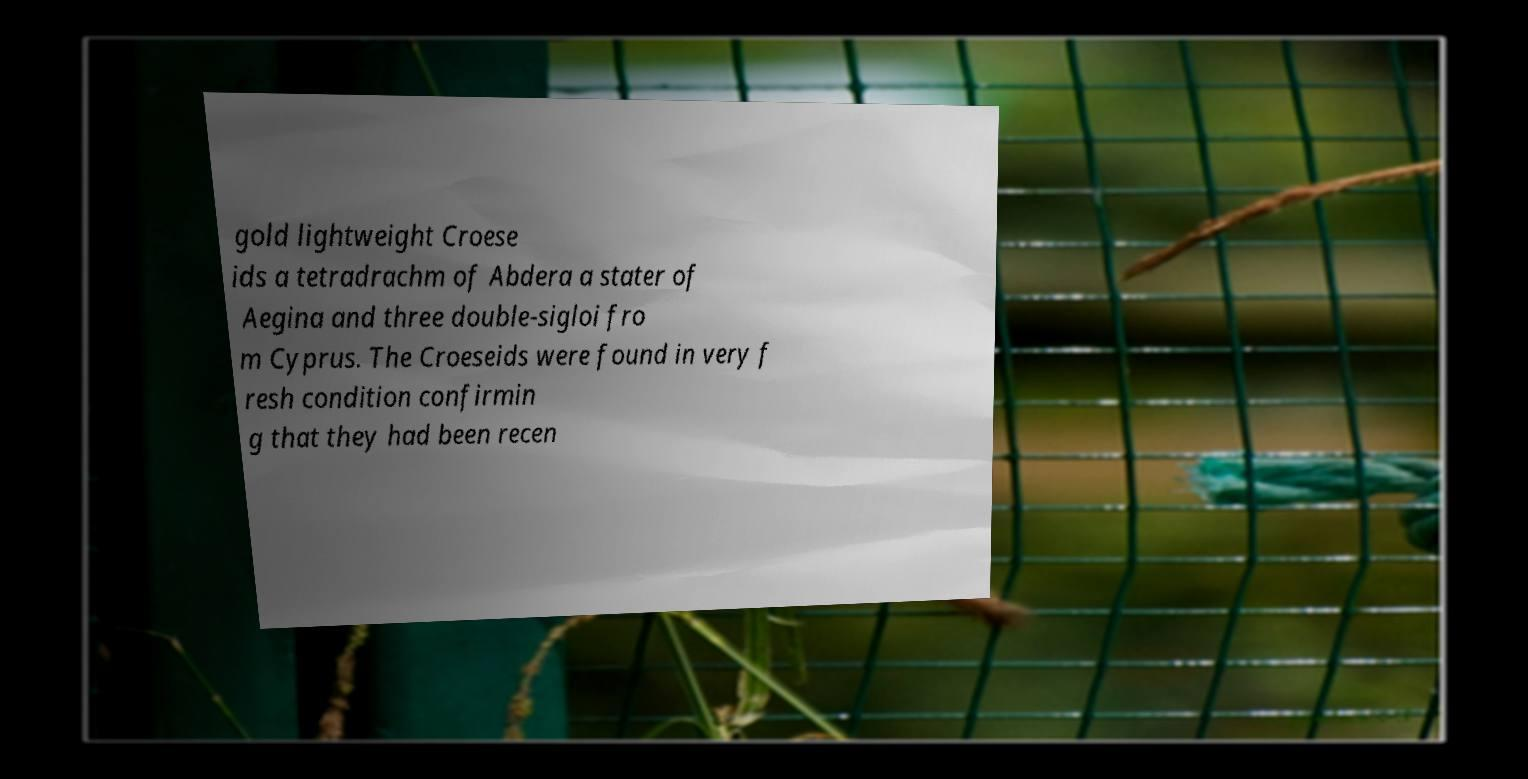Please read and relay the text visible in this image. What does it say? gold lightweight Croese ids a tetradrachm of Abdera a stater of Aegina and three double-sigloi fro m Cyprus. The Croeseids were found in very f resh condition confirmin g that they had been recen 